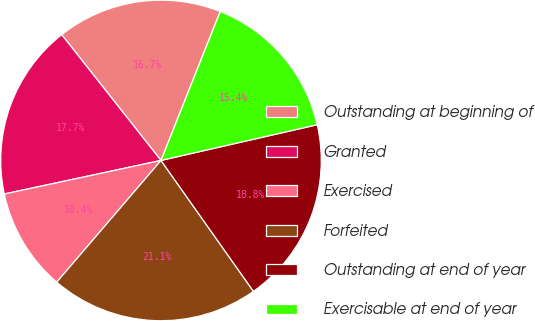Convert chart. <chart><loc_0><loc_0><loc_500><loc_500><pie_chart><fcel>Outstanding at beginning of<fcel>Granted<fcel>Exercised<fcel>Forfeited<fcel>Outstanding at end of year<fcel>Exercisable at end of year<nl><fcel>16.66%<fcel>17.72%<fcel>10.37%<fcel>21.06%<fcel>18.79%<fcel>15.4%<nl></chart> 